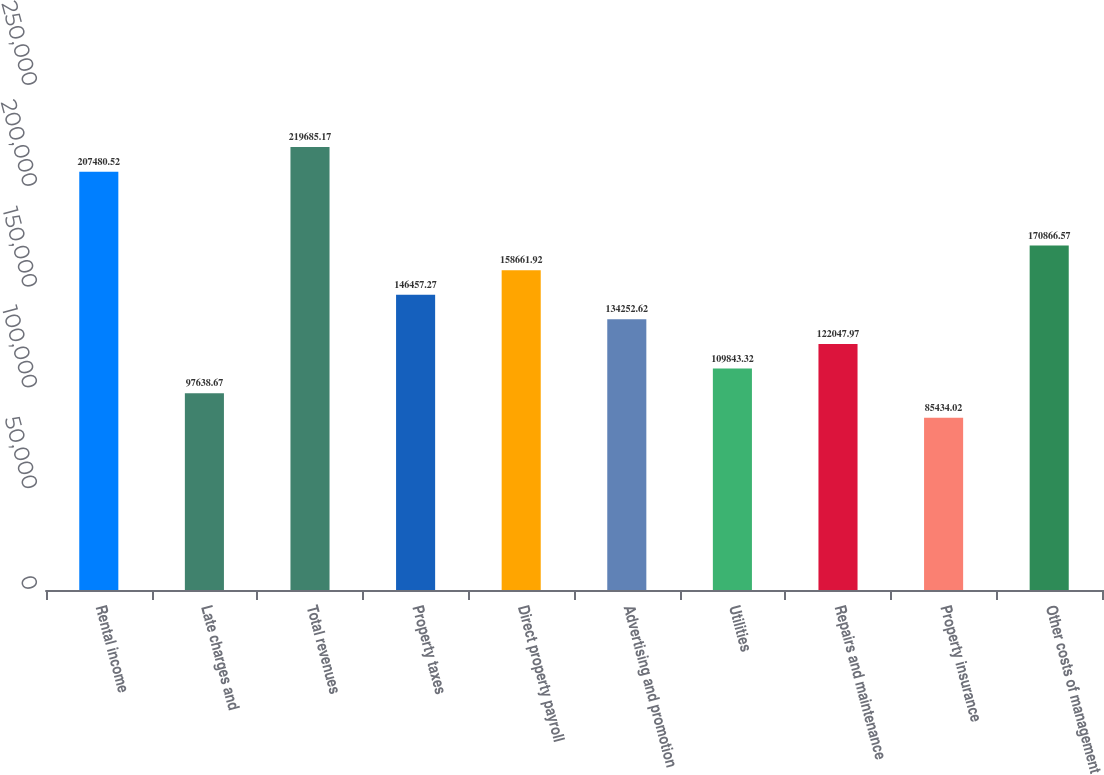Convert chart to OTSL. <chart><loc_0><loc_0><loc_500><loc_500><bar_chart><fcel>Rental income<fcel>Late charges and<fcel>Total revenues<fcel>Property taxes<fcel>Direct property payroll<fcel>Advertising and promotion<fcel>Utilities<fcel>Repairs and maintenance<fcel>Property insurance<fcel>Other costs of management<nl><fcel>207481<fcel>97638.7<fcel>219685<fcel>146457<fcel>158662<fcel>134253<fcel>109843<fcel>122048<fcel>85434<fcel>170867<nl></chart> 